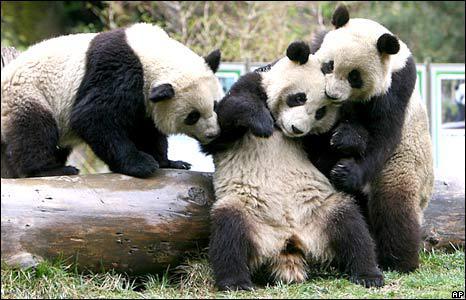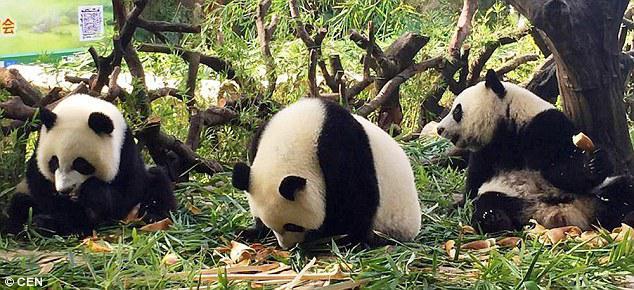The first image is the image on the left, the second image is the image on the right. Evaluate the accuracy of this statement regarding the images: "Each image contains exactly three panda bears.". Is it true? Answer yes or no. Yes. 